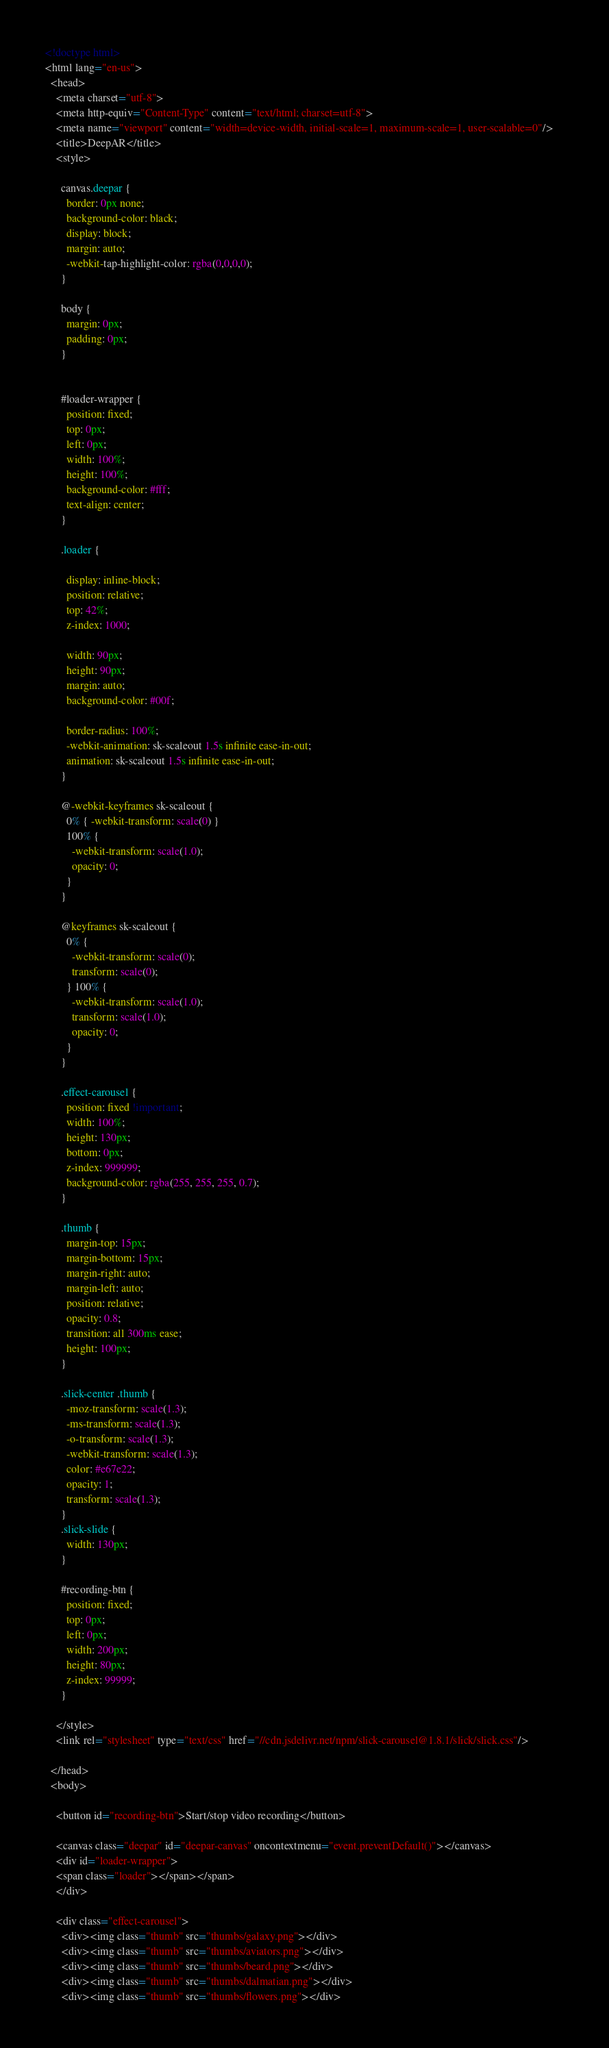Convert code to text. <code><loc_0><loc_0><loc_500><loc_500><_HTML_><!doctype html>
<html lang="en-us">
  <head>
    <meta charset="utf-8">
    <meta http-equiv="Content-Type" content="text/html; charset=utf-8">
    <meta name="viewport" content="width=device-width, initial-scale=1, maximum-scale=1, user-scalable=0"/>    
    <title>DeepAR</title>
    <style>

      canvas.deepar { 
        border: 0px none; 
        background-color: black; 
        display: block; 
        margin: auto; 
        -webkit-tap-highlight-color: rgba(0,0,0,0);
      }

      body {
        margin: 0px;
        padding: 0px;        
      }


      #loader-wrapper {
        position: fixed;
        top: 0px;
        left: 0px;
        width: 100%;
        height: 100%;
        background-color: #fff;
        text-align: center;
      }

      .loader {

        display: inline-block;
        position: relative;
        top: 42%;
        z-index: 1000;

        width: 90px;
        height: 90px;
        margin: auto;
        background-color: #00f;

        border-radius: 100%;  
        -webkit-animation: sk-scaleout 1.5s infinite ease-in-out;
        animation: sk-scaleout 1.5s infinite ease-in-out;
      }

      @-webkit-keyframes sk-scaleout {
        0% { -webkit-transform: scale(0) }
        100% {
          -webkit-transform: scale(1.0);
          opacity: 0;
        }
      }

      @keyframes sk-scaleout {
        0% { 
          -webkit-transform: scale(0);
          transform: scale(0);
        } 100% {
          -webkit-transform: scale(1.0);
          transform: scale(1.0);
          opacity: 0;
        }
      }

      .effect-carousel {
        position: fixed !important;
        width: 100%;
        height: 130px;
        bottom: 0px;
        z-index: 999999;
        background-color: rgba(255, 255, 255, 0.7);
      }

      .thumb {
        margin-top: 15px;
        margin-bottom: 15px;
        margin-right: auto;
        margin-left: auto;
        position: relative;
        opacity: 0.8;
        transition: all 300ms ease;
        height: 100px;
      }

      .slick-center .thumb {
        -moz-transform: scale(1.3);
        -ms-transform: scale(1.3);
        -o-transform: scale(1.3);
        -webkit-transform: scale(1.3);
        color: #e67e22;
        opacity: 1;
        transform: scale(1.3);
      }
      .slick-slide {
        width: 130px;
      }

      #recording-btn {
        position: fixed;
        top: 0px;
        left: 0px;
        width: 200px;
        height: 80px;
        z-index: 99999;
      }

    </style>
    <link rel="stylesheet" type="text/css" href="//cdn.jsdelivr.net/npm/slick-carousel@1.8.1/slick/slick.css"/>

  </head>
  <body>

    <button id="recording-btn">Start/stop video recording</button>

    <canvas class="deepar" id="deepar-canvas" oncontextmenu="event.preventDefault()"></canvas>
    <div id="loader-wrapper">
    <span class="loader"></span></span>
    </div>

    <div class="effect-carousel">
      <div><img class="thumb" src="thumbs/galaxy.png"></div>
      <div><img class="thumb" src="thumbs/aviators.png"></div>
      <div><img class="thumb" src="thumbs/beard.png"></div>
      <div><img class="thumb" src="thumbs/dalmatian.png"></div>
      <div><img class="thumb" src="thumbs/flowers.png"></div></code> 